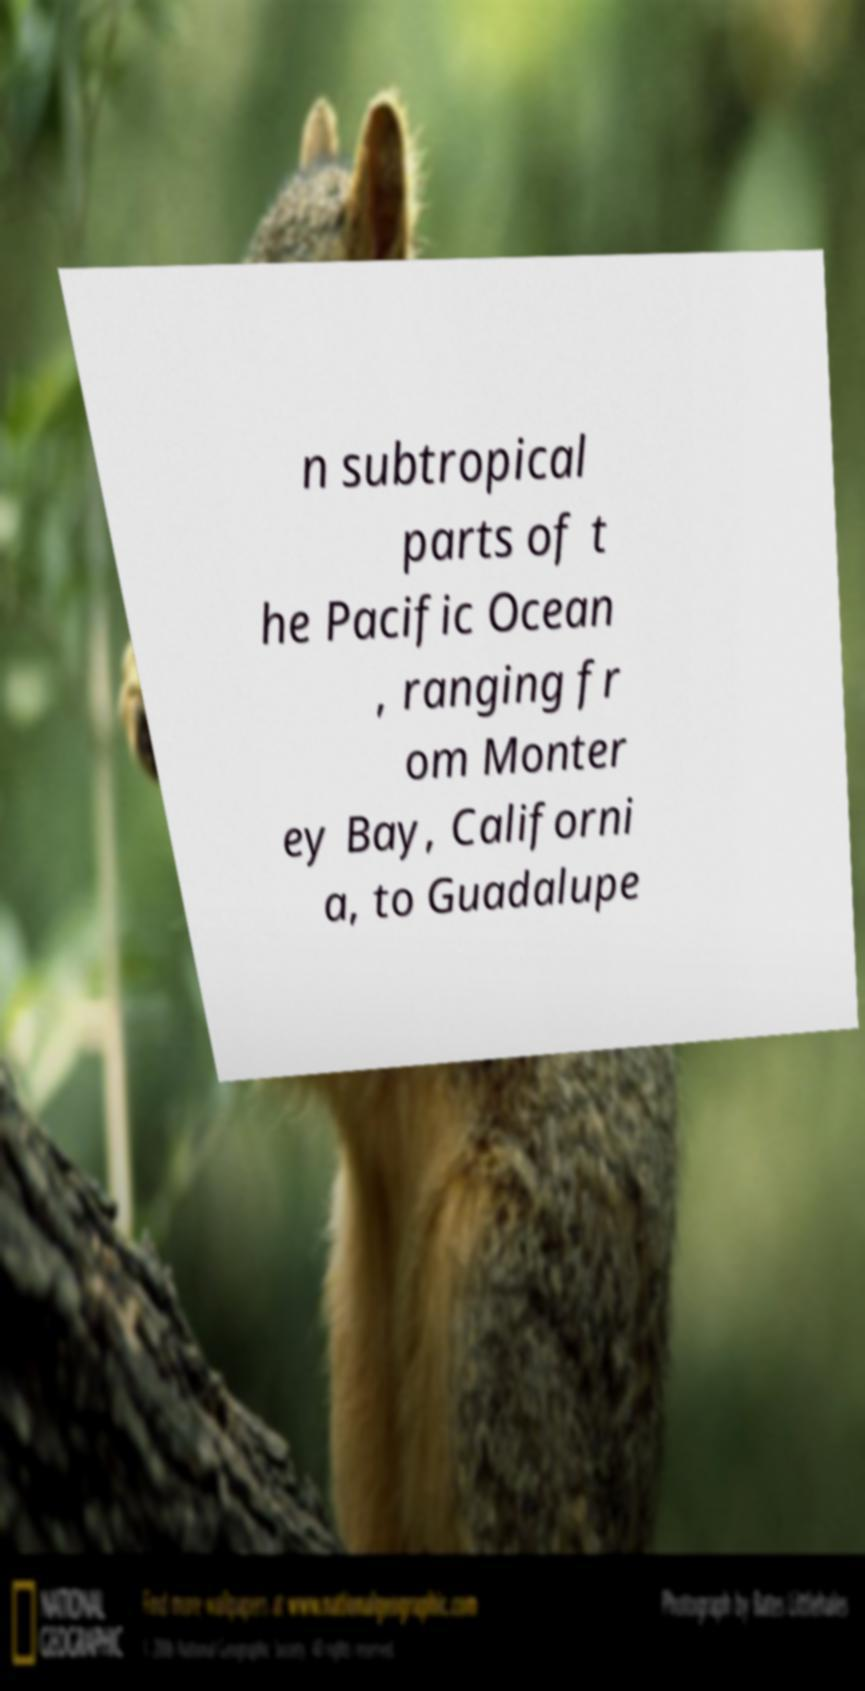What messages or text are displayed in this image? I need them in a readable, typed format. n subtropical parts of t he Pacific Ocean , ranging fr om Monter ey Bay, Californi a, to Guadalupe 